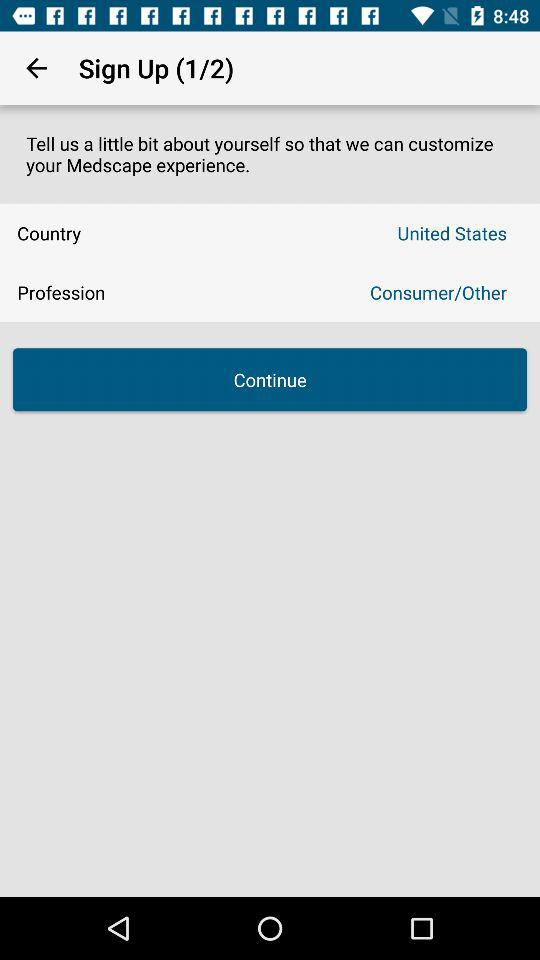What is the user's name?
When the provided information is insufficient, respond with <no answer>. <no answer> 